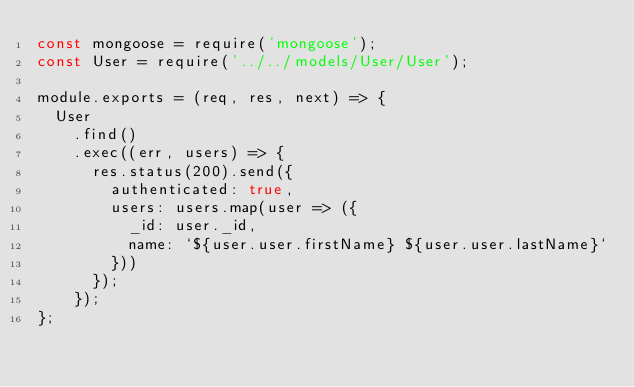<code> <loc_0><loc_0><loc_500><loc_500><_JavaScript_>const mongoose = require('mongoose');
const User = require('../../models/User/User');

module.exports = (req, res, next) => {
  User
    .find()
    .exec((err, users) => {
      res.status(200).send({
        authenticated: true,
        users: users.map(user => ({
          _id: user._id,
          name: `${user.user.firstName} ${user.user.lastName}`
        }))
      });
    });
};
</code> 